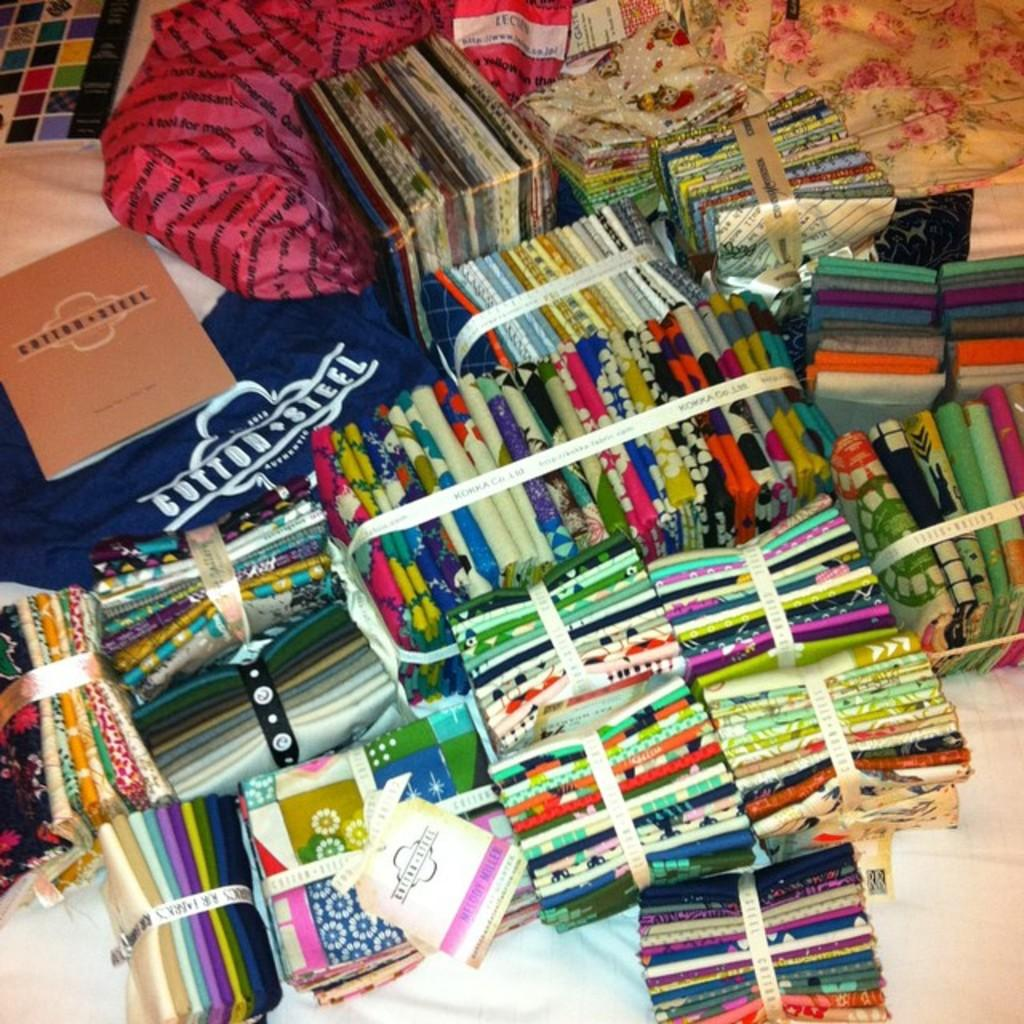<image>
Summarize the visual content of the image. Cotton steel book on top of a cotton steel shirt. 